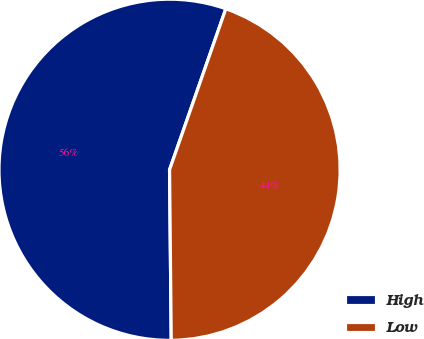Convert chart. <chart><loc_0><loc_0><loc_500><loc_500><pie_chart><fcel>High<fcel>Low<nl><fcel>55.51%<fcel>44.49%<nl></chart> 